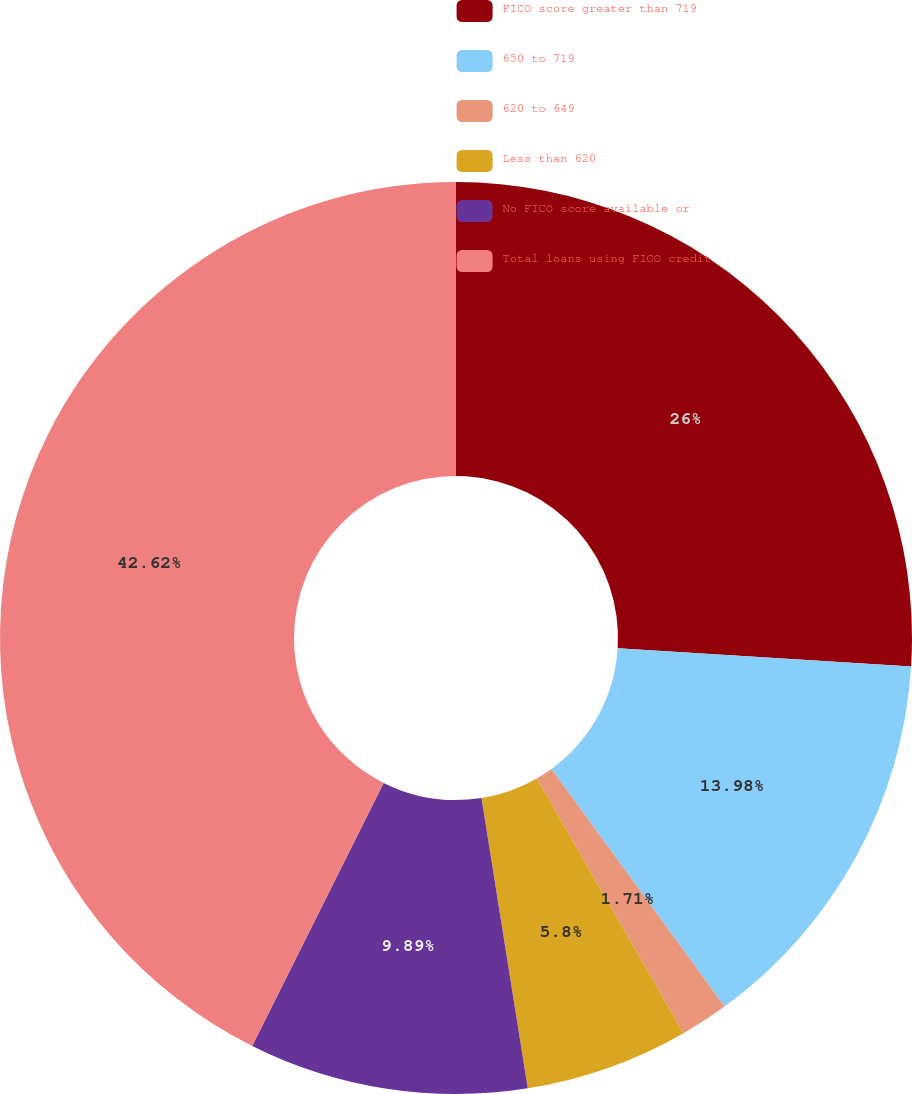Convert chart to OTSL. <chart><loc_0><loc_0><loc_500><loc_500><pie_chart><fcel>FICO score greater than 719<fcel>650 to 719<fcel>620 to 649<fcel>Less than 620<fcel>No FICO score available or<fcel>Total loans using FICO credit<nl><fcel>26.0%<fcel>13.98%<fcel>1.71%<fcel>5.8%<fcel>9.89%<fcel>42.63%<nl></chart> 